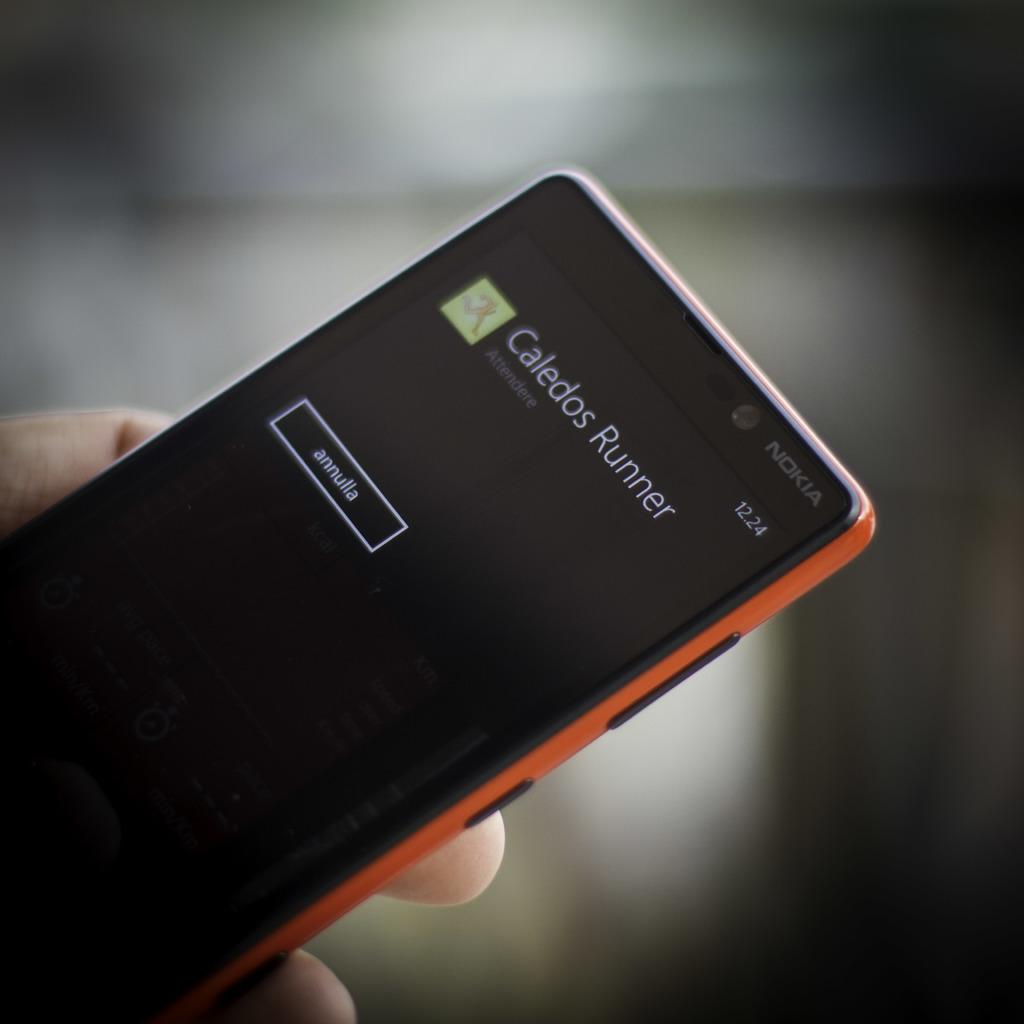<image>
Offer a succinct explanation of the picture presented. a phone that has Caledos Runner on it 